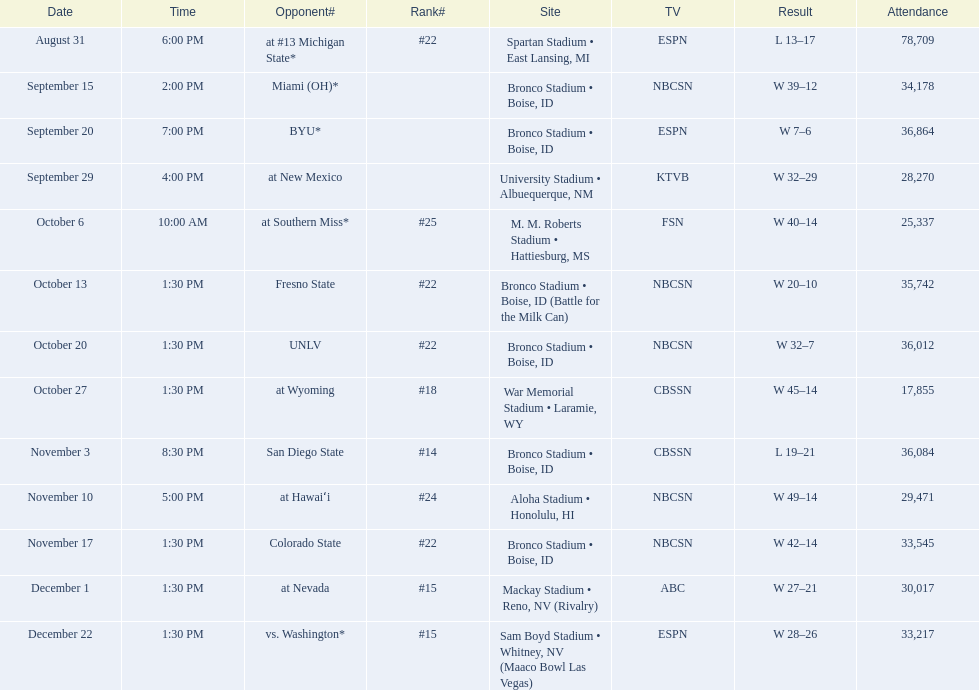Who were all of the opponents? At #13 michigan state*, miami (oh)*, byu*, at new mexico, at southern miss*, fresno state, unlv, at wyoming, san diego state, at hawaiʻi, colorado state, at nevada, vs. washington*. Who did they face on november 3rd? San Diego State. What rank were they on november 3rd? #14. 